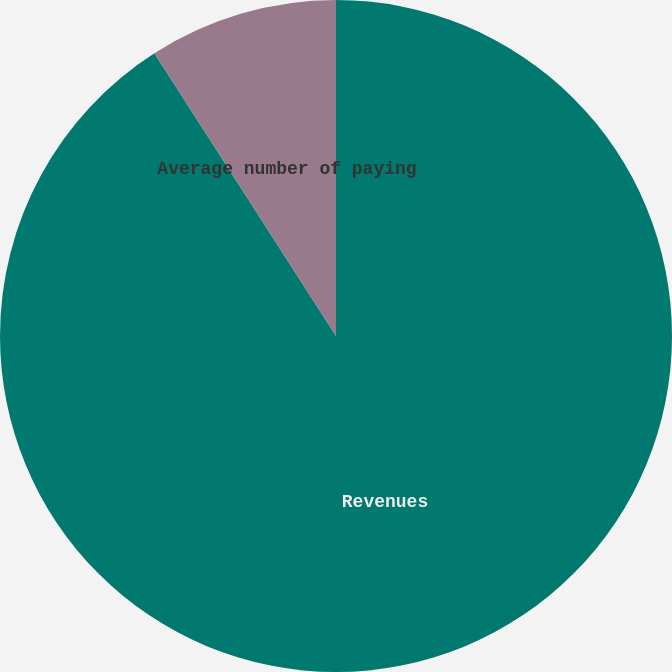Convert chart to OTSL. <chart><loc_0><loc_0><loc_500><loc_500><pie_chart><fcel>Revenues<fcel>Average number of paying<fcel>Average monthly revenue per<nl><fcel>90.91%<fcel>9.09%<fcel>0.0%<nl></chart> 